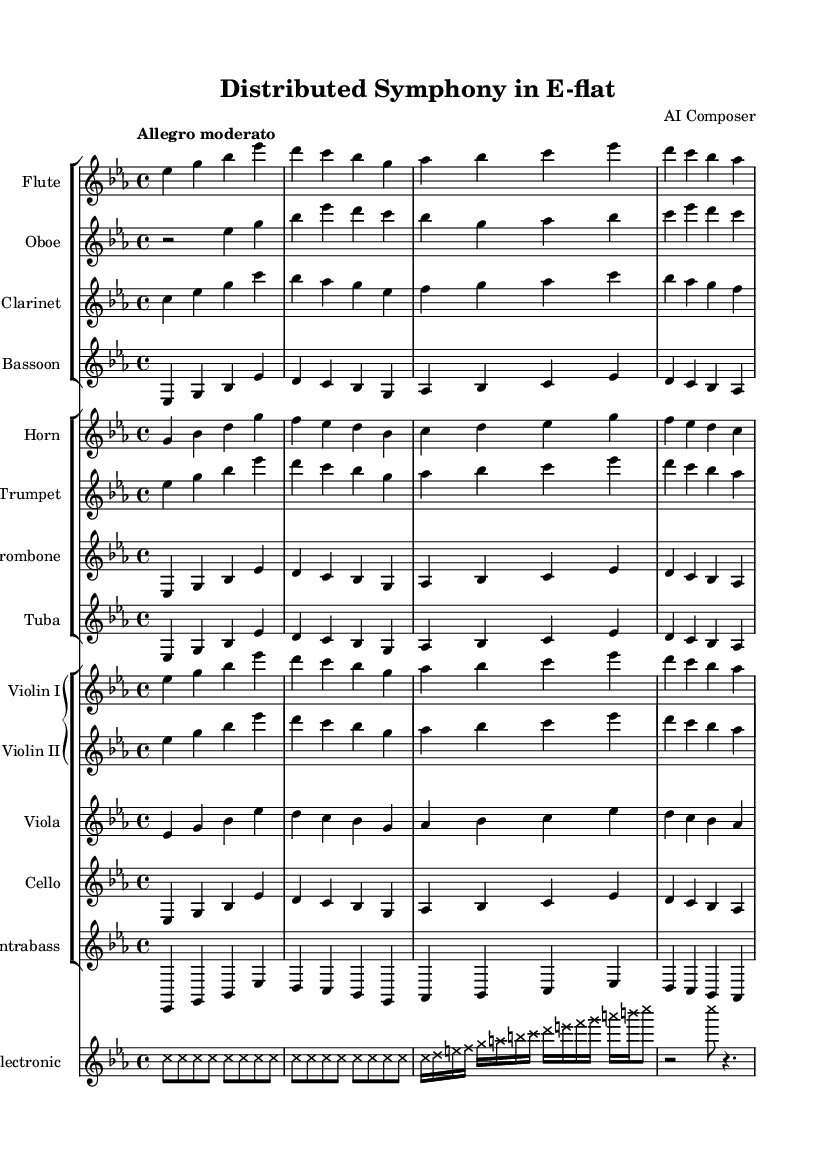What is the key signature of this music? The key signature is indicated at the beginning of the piece where it is specified as E-flat major, which has three flats (B-flat, E-flat, and A-flat).
Answer: E-flat major What is the time signature of this music? The time signature is found at the beginning as well and is written as 4/4, which means there are four beats in each measure.
Answer: 4/4 What is the tempo marking for this symphony? The tempo marking is indicated at the beginning with "Allegro moderato," indicating a moderately fast pace for the piece.
Answer: Allegro moderato Which instruments are used in this symphony? The instruments are specified in the score sections, listing Flute, Oboe, Clarinet, Bassoon, Horn, Trumpet, Trombone, Tuba, Violin I, Violin II, Viola, Cello, Contrabass, and Electronic.
Answer: Flute, Oboe, Clarinet, Bassoon, Horn, Trumpet, Trombone, Tuba, Violin I, Violin II, Viola, Cello, Contrabass, Electronic How many measures does the electronic section have? The electronic section has a total of 6 measures as counted from the electronic music staff provided in the score.
Answer: 6 measures What is the role of the electronic part in this symphony? The electronic part is characterized by marked notes and utilizes a cross note head style, representing a unique addition intended to symbolize data flow and complexity in the music composition.
Answer: Data flow representation 